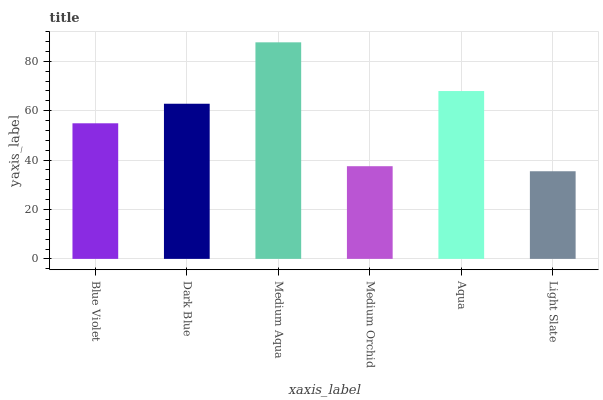Is Light Slate the minimum?
Answer yes or no. Yes. Is Medium Aqua the maximum?
Answer yes or no. Yes. Is Dark Blue the minimum?
Answer yes or no. No. Is Dark Blue the maximum?
Answer yes or no. No. Is Dark Blue greater than Blue Violet?
Answer yes or no. Yes. Is Blue Violet less than Dark Blue?
Answer yes or no. Yes. Is Blue Violet greater than Dark Blue?
Answer yes or no. No. Is Dark Blue less than Blue Violet?
Answer yes or no. No. Is Dark Blue the high median?
Answer yes or no. Yes. Is Blue Violet the low median?
Answer yes or no. Yes. Is Blue Violet the high median?
Answer yes or no. No. Is Aqua the low median?
Answer yes or no. No. 